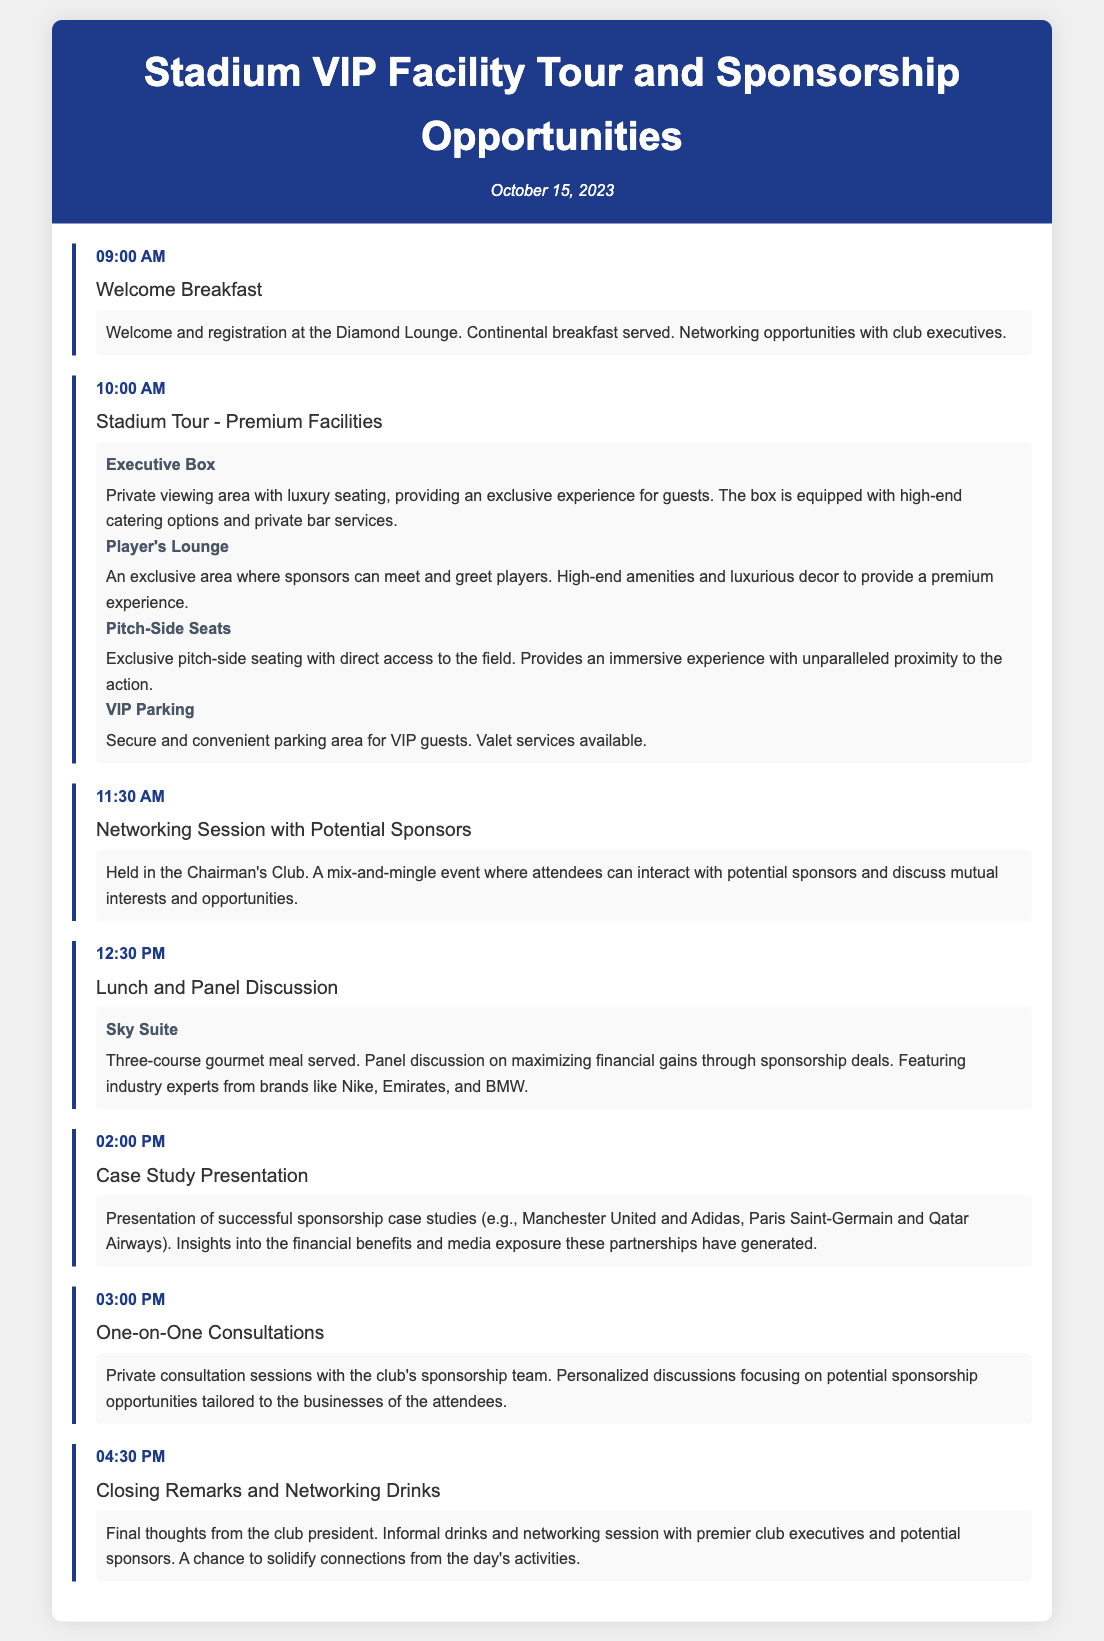What time does the Welcome Breakfast start? The Welcome Breakfast starts at 09:00 AM as listed in the itinerary.
Answer: 09:00 AM What is the location for the Networking Session with Potential Sponsors? The Networking Session with Potential Sponsors is held in the Chairman's Club, as indicated in the details.
Answer: Chairman's Club Who will be featured in the Panel Discussion during lunch? The panel discussion during lunch features industry experts from brands like Nike, Emirates, and BMW.
Answer: Nike, Emirates, and BMW What activity is scheduled after the Lunch and Panel Discussion? After the Lunch and Panel Discussion, a Case Study Presentation is scheduled, which is detailed in the itinerary.
Answer: Case Study Presentation What is the purpose of the One-on-One Consultations? The One-on-One Consultations focus on personalized discussions about potential sponsorship opportunities tailored to the businesses of the attendees.
Answer: Potential sponsorship opportunities Which premium facility offers private viewing areas? The Executive Box offers private viewing areas with luxury seating, as mentioned in the document.
Answer: Executive Box What type of meal is served during the lunch session? A three-course gourmet meal is served during the lunch session according to the details provided.
Answer: Three-course gourmet meal What activity concludes the itinerary? The itinerary concludes with Closing Remarks and Networking Drinks as specified in the final item.
Answer: Closing Remarks and Networking Drinks 